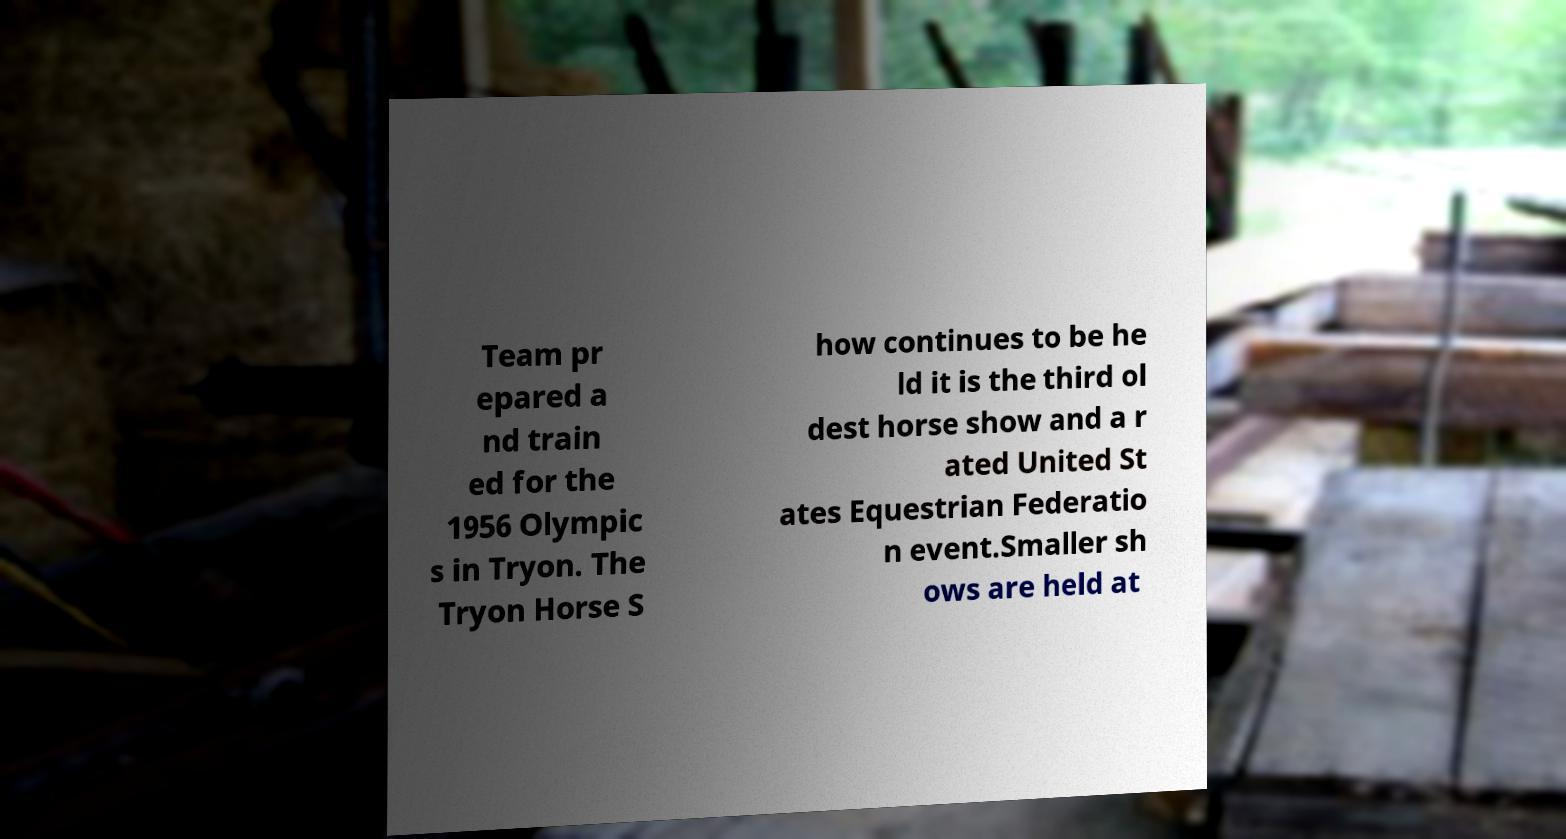Please identify and transcribe the text found in this image. Team pr epared a nd train ed for the 1956 Olympic s in Tryon. The Tryon Horse S how continues to be he ld it is the third ol dest horse show and a r ated United St ates Equestrian Federatio n event.Smaller sh ows are held at 